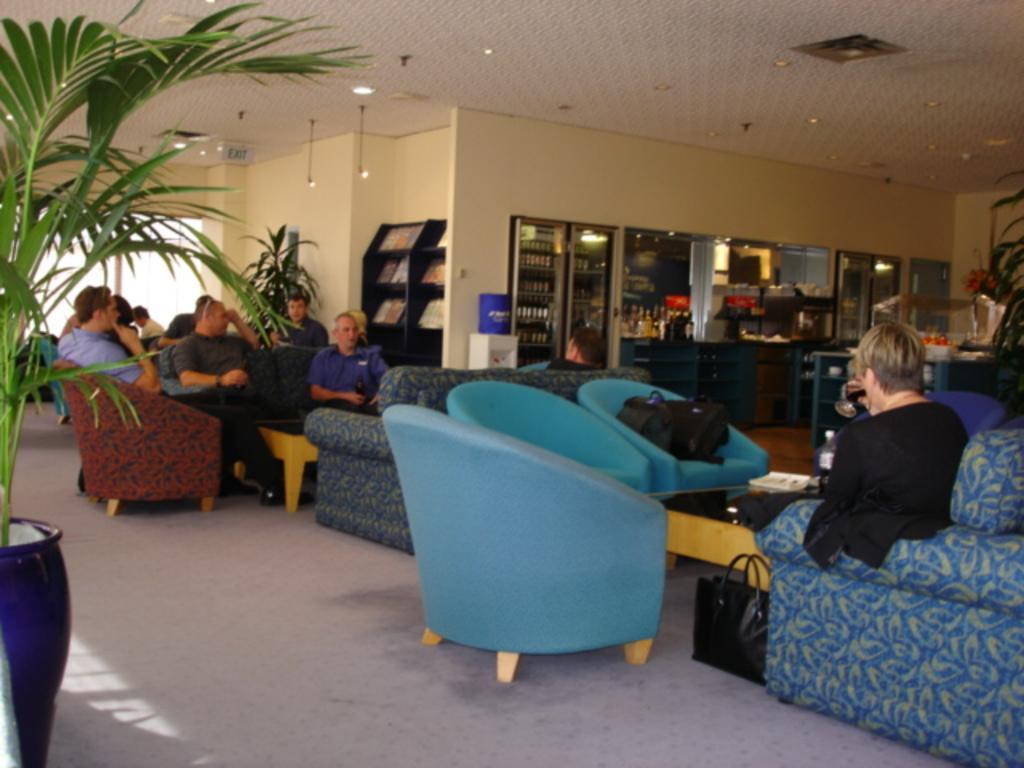Could you give a brief overview of what you see in this image? This picture looks like it is a waiting space. In the center of the picture there are many couches, tables and many people seated on the tables and couches, there are bags, books and bottles. In the center of the background there are closets, in the closet there are bottles and books. On the left there is a houseplant. In the center of the background there is a water machine. On the top there is ceiling and lights. 